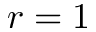<formula> <loc_0><loc_0><loc_500><loc_500>r = 1</formula> 